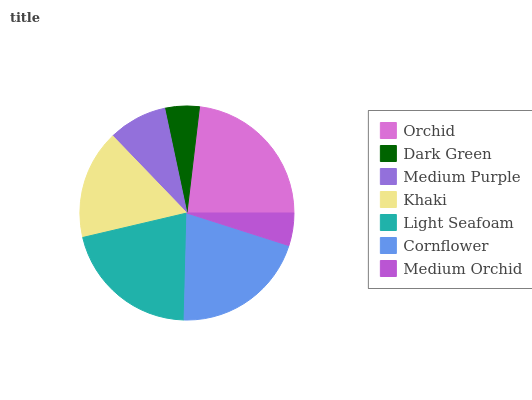Is Medium Orchid the minimum?
Answer yes or no. Yes. Is Orchid the maximum?
Answer yes or no. Yes. Is Dark Green the minimum?
Answer yes or no. No. Is Dark Green the maximum?
Answer yes or no. No. Is Orchid greater than Dark Green?
Answer yes or no. Yes. Is Dark Green less than Orchid?
Answer yes or no. Yes. Is Dark Green greater than Orchid?
Answer yes or no. No. Is Orchid less than Dark Green?
Answer yes or no. No. Is Khaki the high median?
Answer yes or no. Yes. Is Khaki the low median?
Answer yes or no. Yes. Is Cornflower the high median?
Answer yes or no. No. Is Dark Green the low median?
Answer yes or no. No. 